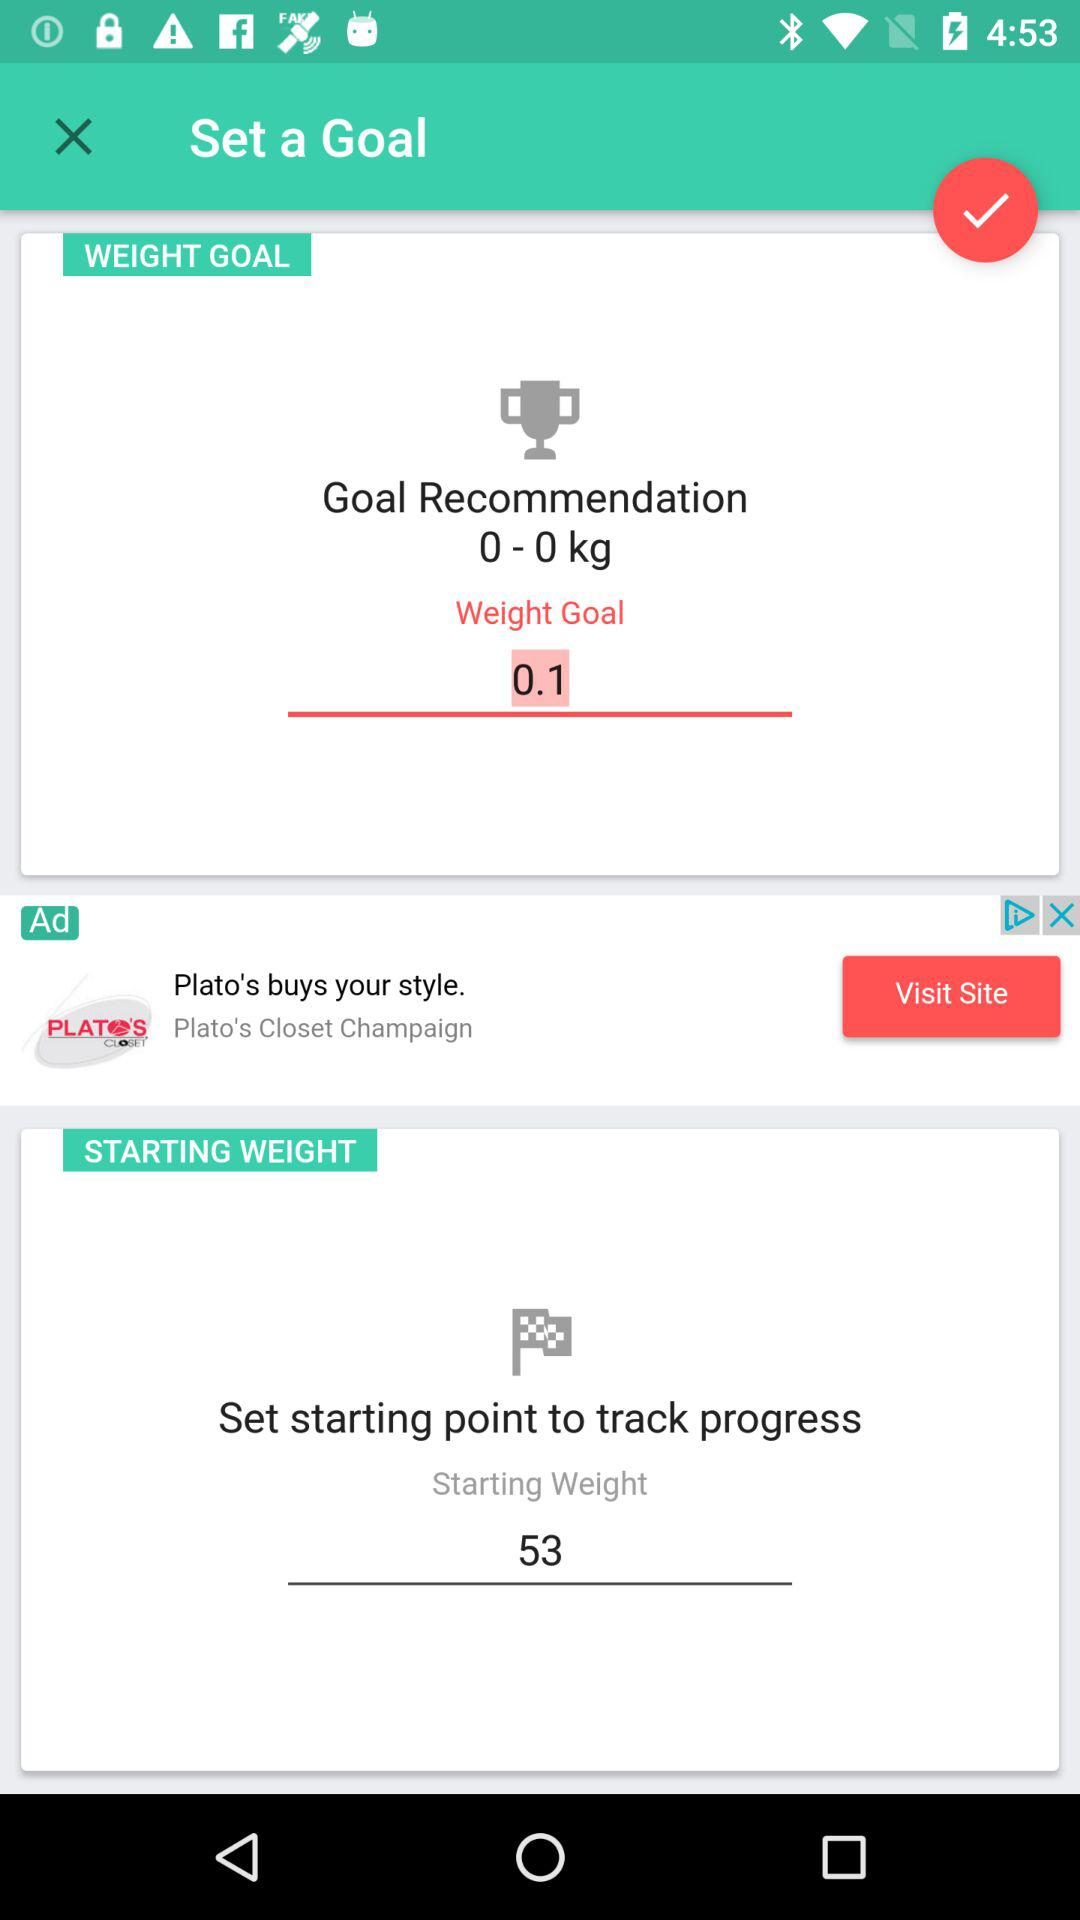How to set track progress?
When the provided information is insufficient, respond with <no answer>. <no answer> 